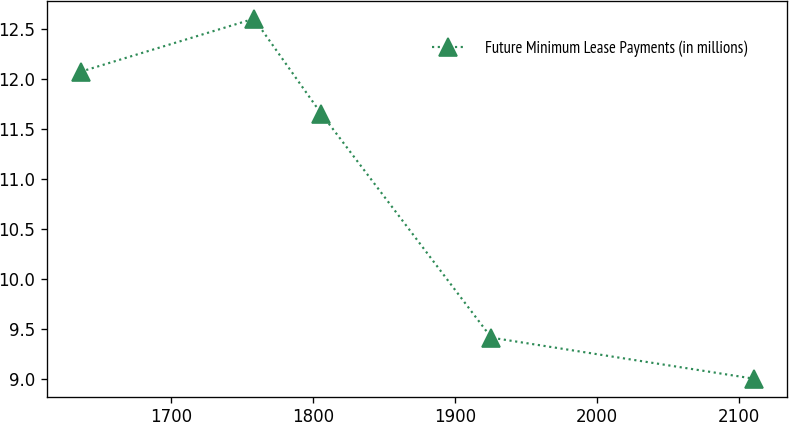<chart> <loc_0><loc_0><loc_500><loc_500><line_chart><ecel><fcel>Future Minimum Lease Payments (in millions)<nl><fcel>1636.08<fcel>12.07<nl><fcel>1758.24<fcel>12.6<nl><fcel>1805.69<fcel>11.65<nl><fcel>1925.65<fcel>9.41<nl><fcel>2110.58<fcel>9<nl></chart> 